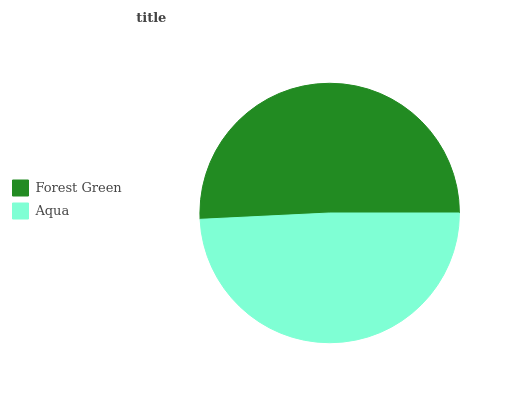Is Aqua the minimum?
Answer yes or no. Yes. Is Forest Green the maximum?
Answer yes or no. Yes. Is Aqua the maximum?
Answer yes or no. No. Is Forest Green greater than Aqua?
Answer yes or no. Yes. Is Aqua less than Forest Green?
Answer yes or no. Yes. Is Aqua greater than Forest Green?
Answer yes or no. No. Is Forest Green less than Aqua?
Answer yes or no. No. Is Forest Green the high median?
Answer yes or no. Yes. Is Aqua the low median?
Answer yes or no. Yes. Is Aqua the high median?
Answer yes or no. No. Is Forest Green the low median?
Answer yes or no. No. 